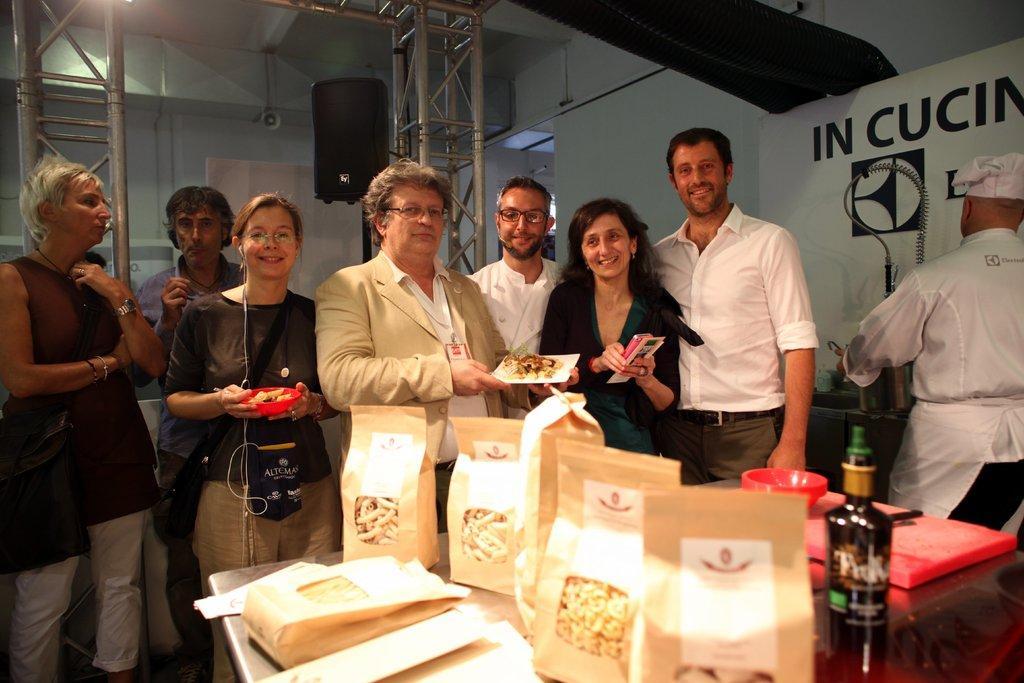Could you give a brief overview of what you see in this image? In this image I can see a table in the front and on it I can see few paper bags, a bottle and few red colour things. In the background I can see number of people are standing and in the front I can see three of them are holding things. On the right side of this image I can see a white colour board and on it I can see something is written. On the top side of this image I can see few poles and few speakers. 